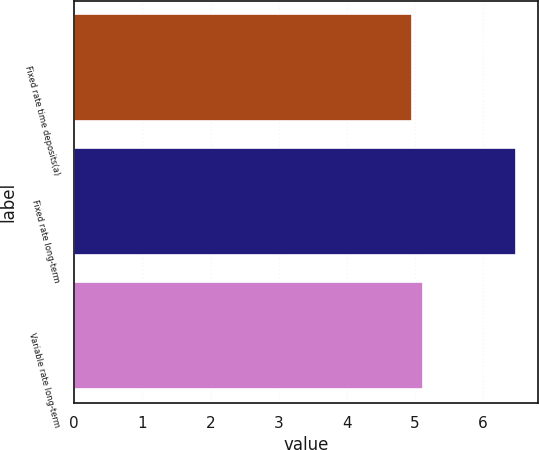Convert chart. <chart><loc_0><loc_0><loc_500><loc_500><bar_chart><fcel>Fixed rate time deposits(a)<fcel>Fixed rate long-term<fcel>Variable rate long-term<nl><fcel>4.96<fcel>6.48<fcel>5.11<nl></chart> 